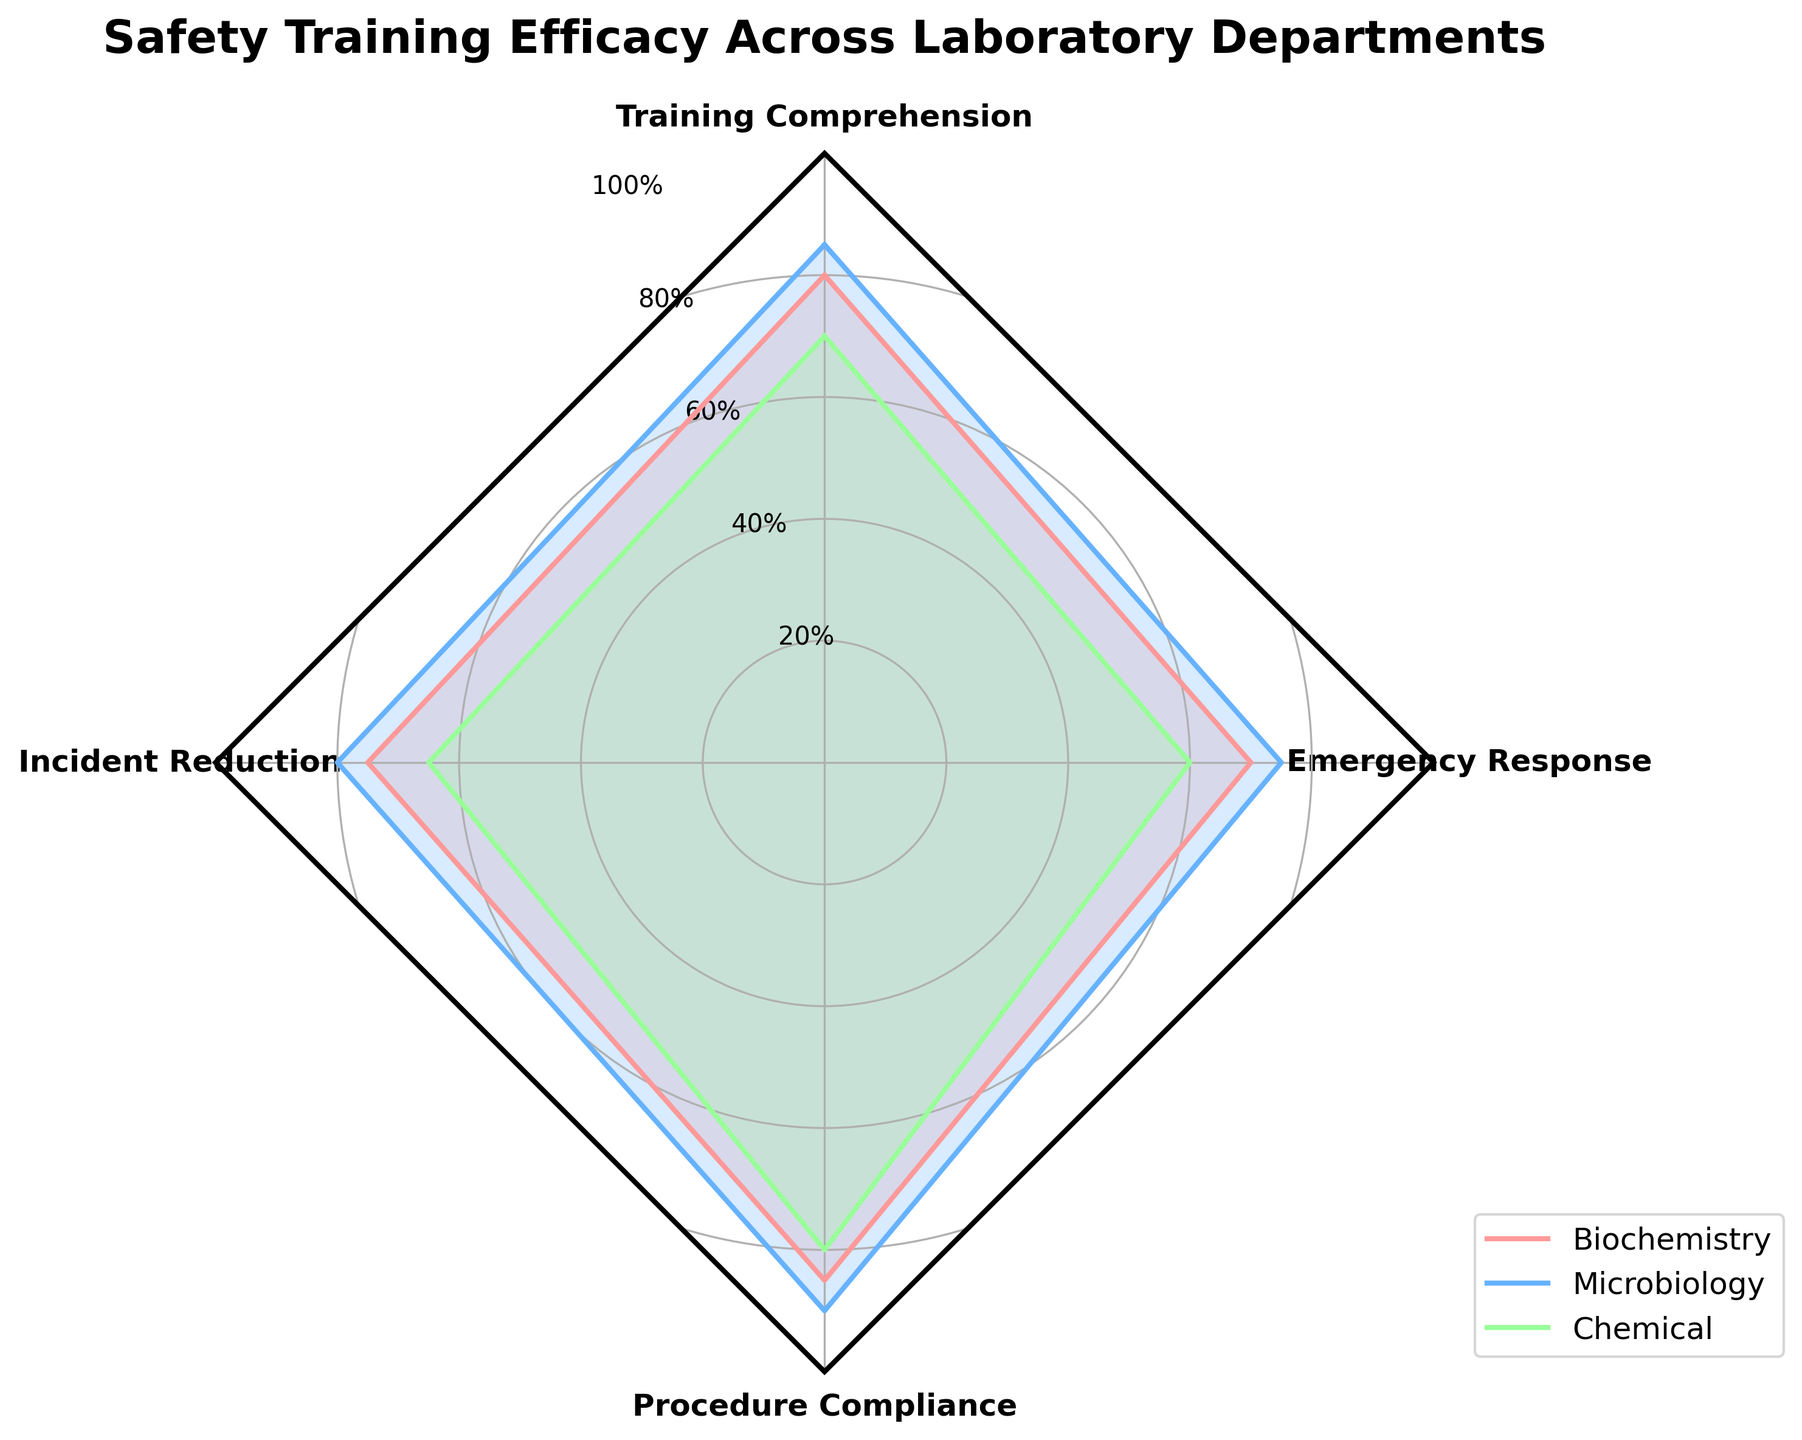What is the title of the radar chart? The title is displayed at the top center of the radar chart. It provides a summary of what the chart represents, which helps readers quickly understand the topic of the visualization.
Answer: Safety Training Efficacy Across Laboratory Departments Which laboratory department has the highest value in Training Comprehension? By looking at the Training Comprehension axis and observing which department plot reaches the highest point on this axis, we can determine the department with the highest value.
Answer: Microbiology What is the difference in Emergency Response scores between the Biochemistry and Chemical departments? First, look at the Emergency Response axis and find the values for Biochemistry (70) and Chemical (60). Then, subtract the smaller value (60) from the larger value (70) to calculate the difference.
Answer: 10 Which department has the lowest Incident Reduction score, and what is the value? Examine the Incident Reduction axis and identify the lowest point among the department plots. The Chemical department has the lowest Incident Reduction score.
Answer: Chemical, 65 What is the average value of Procedure Compliance for all departments? Add the Procedure Compliance values for all departments: Biochemistry (85), Microbiology (90), and Chemical (80). Then, divide the sum by the number of departments (3) to find the average.
Answer: (85 + 90 + 80) / 3 = 85 Which department shows the most balanced performance across all categories? Identify the department whose plotted values are evenly distributed and relatively similar across all axes in the radar chart. Both Biochemistry and Microbiology have balanced performances, but Biochemistry is slightly more balanced as it doesn't have as high peaks and troughs as Microbiology.
Answer: Biochemistry How does the Emergency Response score for Microbiology compare to Biochemistry? Look at the Emergency Response axis and compare the values of Microbiology (75) and Biochemistry (70). Microbiology's score is higher.
Answer: Higher by 5 What is the sum of Incident Reduction and Emergency Response scores for the Chemical department? Find the values for Incident Reduction (65) and Emergency Response (60) in the Chemical department, then add them together.
Answer: 65 + 60 = 125 Which category does the Biochemistry department excel the most in? Identify the highest value point on Biochemistry's plot. The Procedure Compliance value of 85 is the highest among its categories.
Answer: Procedure Compliance What is the range of values for the Training Comprehension category across all departments? Find the highest (85 for Microbiology) and lowest (70 for Chemical) values in Training Comprehension, then calculate the range by subtracting the lowest from the highest.
Answer: 85 - 70 = 15 